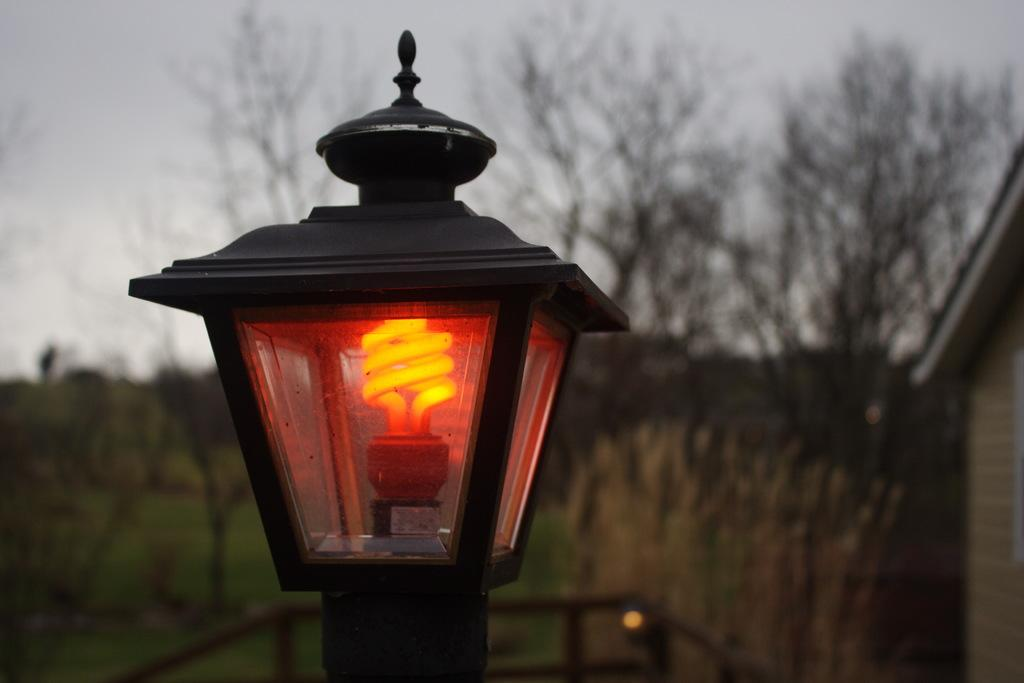What is the main object in the image? There is a light bulb in the image. What is the color of the object containing the light bulb? The light bulb is in a black color object. What can be seen in the background of the image? There are trees, the sky, and other objects visible in the background of the image. How many rocks are present in the image? There are no rocks visible in the image. What type of stove can be seen in the image? There is no stove present in the image. 